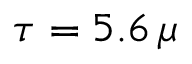Convert formula to latex. <formula><loc_0><loc_0><loc_500><loc_500>\tau = 5 . 6 \, \mu</formula> 